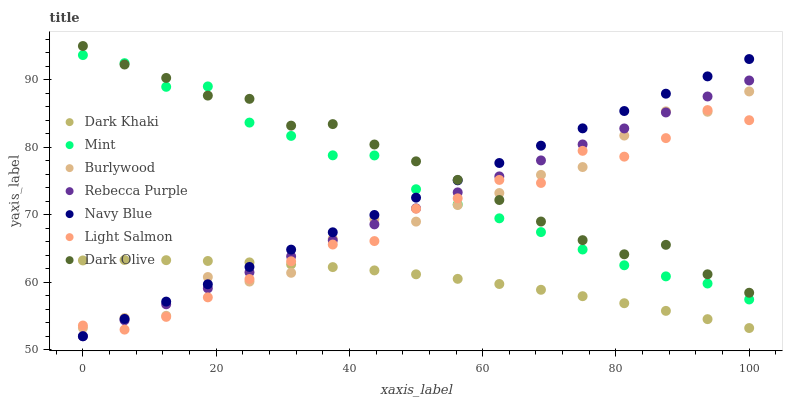Does Dark Khaki have the minimum area under the curve?
Answer yes or no. Yes. Does Dark Olive have the maximum area under the curve?
Answer yes or no. Yes. Does Burlywood have the minimum area under the curve?
Answer yes or no. No. Does Burlywood have the maximum area under the curve?
Answer yes or no. No. Is Navy Blue the smoothest?
Answer yes or no. Yes. Is Burlywood the roughest?
Answer yes or no. Yes. Is Burlywood the smoothest?
Answer yes or no. No. Is Navy Blue the roughest?
Answer yes or no. No. Does Navy Blue have the lowest value?
Answer yes or no. Yes. Does Burlywood have the lowest value?
Answer yes or no. No. Does Dark Olive have the highest value?
Answer yes or no. Yes. Does Burlywood have the highest value?
Answer yes or no. No. Is Dark Khaki less than Dark Olive?
Answer yes or no. Yes. Is Dark Olive greater than Dark Khaki?
Answer yes or no. Yes. Does Burlywood intersect Dark Olive?
Answer yes or no. Yes. Is Burlywood less than Dark Olive?
Answer yes or no. No. Is Burlywood greater than Dark Olive?
Answer yes or no. No. Does Dark Khaki intersect Dark Olive?
Answer yes or no. No. 